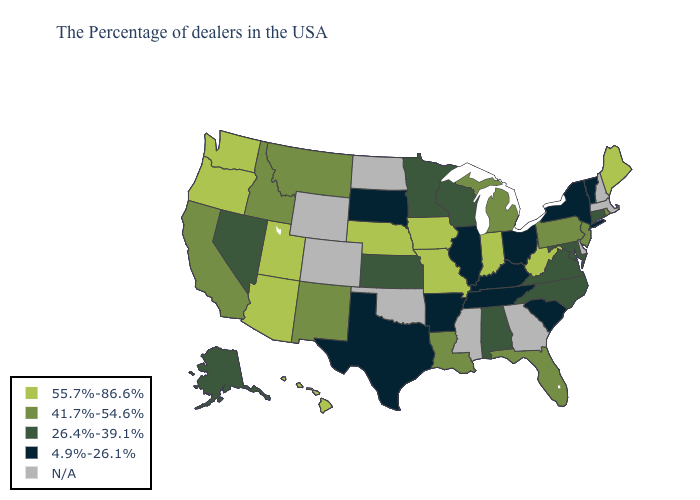What is the value of West Virginia?
Give a very brief answer. 55.7%-86.6%. Name the states that have a value in the range N/A?
Answer briefly. Massachusetts, New Hampshire, Delaware, Georgia, Mississippi, Oklahoma, North Dakota, Wyoming, Colorado. Which states have the highest value in the USA?
Concise answer only. Maine, West Virginia, Indiana, Missouri, Iowa, Nebraska, Utah, Arizona, Washington, Oregon, Hawaii. What is the value of Georgia?
Write a very short answer. N/A. Does the map have missing data?
Be succinct. Yes. Among the states that border Nebraska , which have the highest value?
Quick response, please. Missouri, Iowa. Does Iowa have the lowest value in the USA?
Write a very short answer. No. Which states have the lowest value in the Northeast?
Concise answer only. Vermont, New York. Among the states that border New Mexico , which have the lowest value?
Concise answer only. Texas. Name the states that have a value in the range 4.9%-26.1%?
Answer briefly. Vermont, New York, South Carolina, Ohio, Kentucky, Tennessee, Illinois, Arkansas, Texas, South Dakota. What is the lowest value in states that border South Dakota?
Short answer required. 26.4%-39.1%. Which states have the lowest value in the USA?
Give a very brief answer. Vermont, New York, South Carolina, Ohio, Kentucky, Tennessee, Illinois, Arkansas, Texas, South Dakota. What is the value of Massachusetts?
Concise answer only. N/A. Which states have the lowest value in the USA?
Be succinct. Vermont, New York, South Carolina, Ohio, Kentucky, Tennessee, Illinois, Arkansas, Texas, South Dakota. 